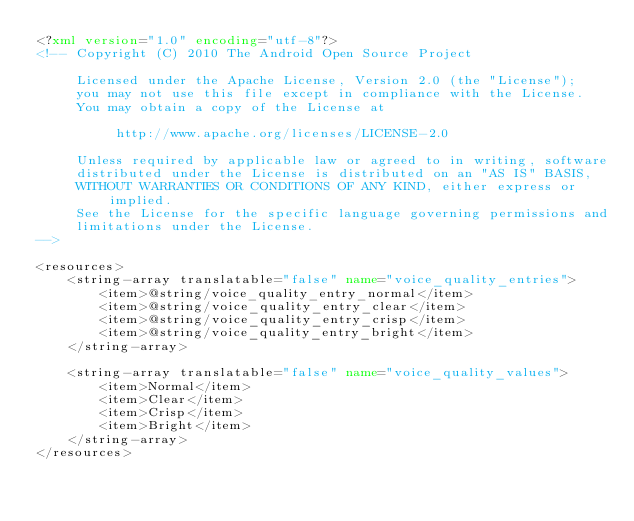<code> <loc_0><loc_0><loc_500><loc_500><_XML_><?xml version="1.0" encoding="utf-8"?>
<!-- Copyright (C) 2010 The Android Open Source Project

     Licensed under the Apache License, Version 2.0 (the "License");
     you may not use this file except in compliance with the License.
     You may obtain a copy of the License at

          http://www.apache.org/licenses/LICENSE-2.0

     Unless required by applicable law or agreed to in writing, software
     distributed under the License is distributed on an "AS IS" BASIS,
     WITHOUT WARRANTIES OR CONDITIONS OF ANY KIND, either express or implied.
     See the License for the specific language governing permissions and
     limitations under the License.
-->

<resources>
    <string-array translatable="false" name="voice_quality_entries">
        <item>@string/voice_quality_entry_normal</item>
        <item>@string/voice_quality_entry_clear</item>
        <item>@string/voice_quality_entry_crisp</item>
        <item>@string/voice_quality_entry_bright</item>
    </string-array>

    <string-array translatable="false" name="voice_quality_values">
        <item>Normal</item>
        <item>Clear</item>
        <item>Crisp</item>
        <item>Bright</item>
    </string-array>
</resources>
</code> 